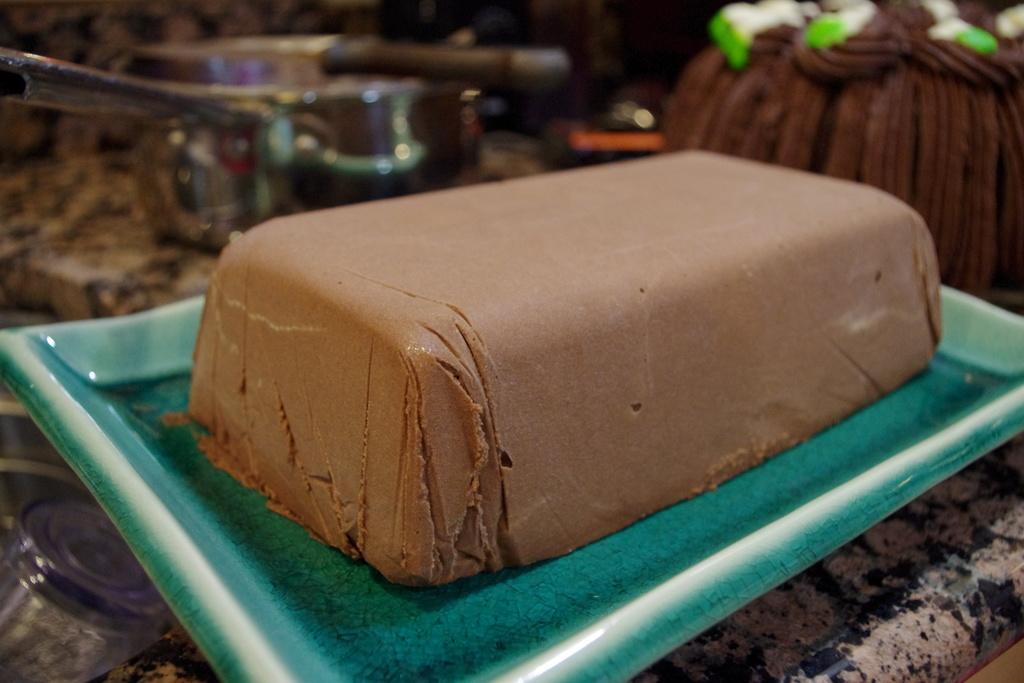What is the main object on the green color tray in the image? The main object on the green color tray is not specified in the facts provided. Can you describe the background of the image? The background of the image is blurred. Are there any other objects visible in the background? Yes, there are other objects visible in the background. Can you see any children playing on a swing in the image? There is no mention of a swing or children playing in the image, so we cannot answer that question. 